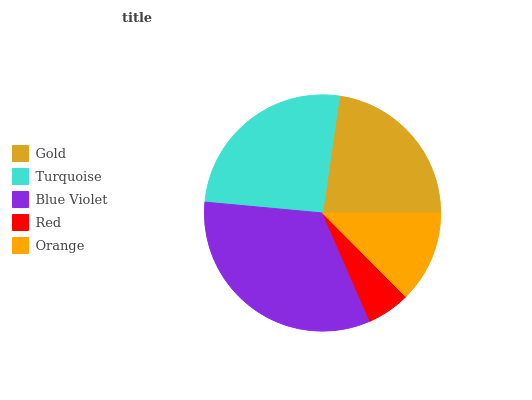Is Red the minimum?
Answer yes or no. Yes. Is Blue Violet the maximum?
Answer yes or no. Yes. Is Turquoise the minimum?
Answer yes or no. No. Is Turquoise the maximum?
Answer yes or no. No. Is Turquoise greater than Gold?
Answer yes or no. Yes. Is Gold less than Turquoise?
Answer yes or no. Yes. Is Gold greater than Turquoise?
Answer yes or no. No. Is Turquoise less than Gold?
Answer yes or no. No. Is Gold the high median?
Answer yes or no. Yes. Is Gold the low median?
Answer yes or no. Yes. Is Orange the high median?
Answer yes or no. No. Is Orange the low median?
Answer yes or no. No. 